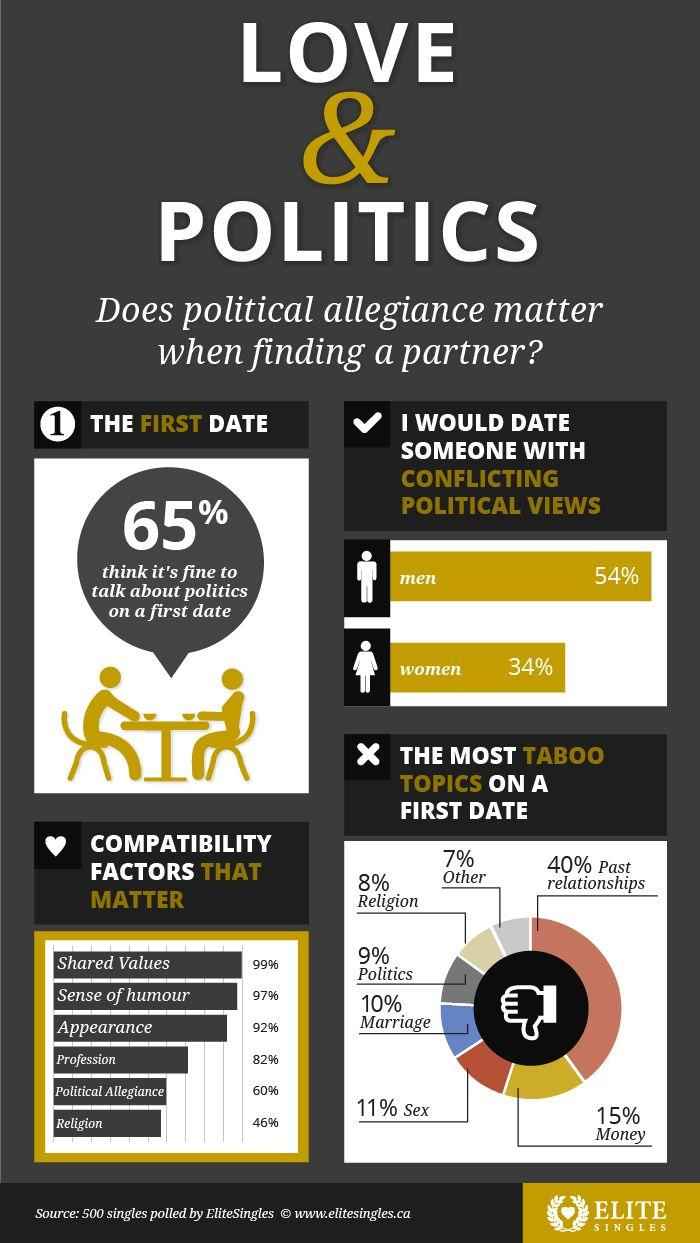Identify some key points in this picture. It is considered the least taboo topic on the first date to be 'other'. It is considered to be the most taboo topic on a first date to discuss past relationships. Nearly 35% of people believe it is acceptable to discuss politics on the first date. The fourth-highest compatibility factor that affects love is profession. According to the data, 54% of males are ready to meet a partner with a different political viewpoint. 